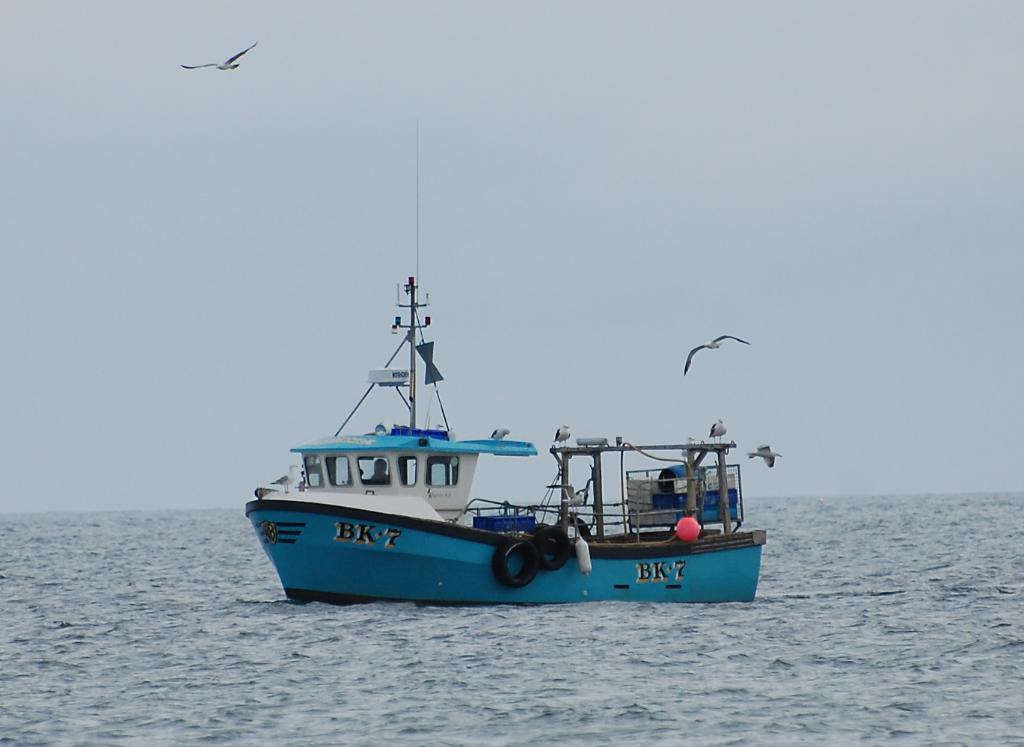Describe this image in one or two sentences. In this image we can see a ship on the water and there are birds flying in the air. In the background we can see the sky. 